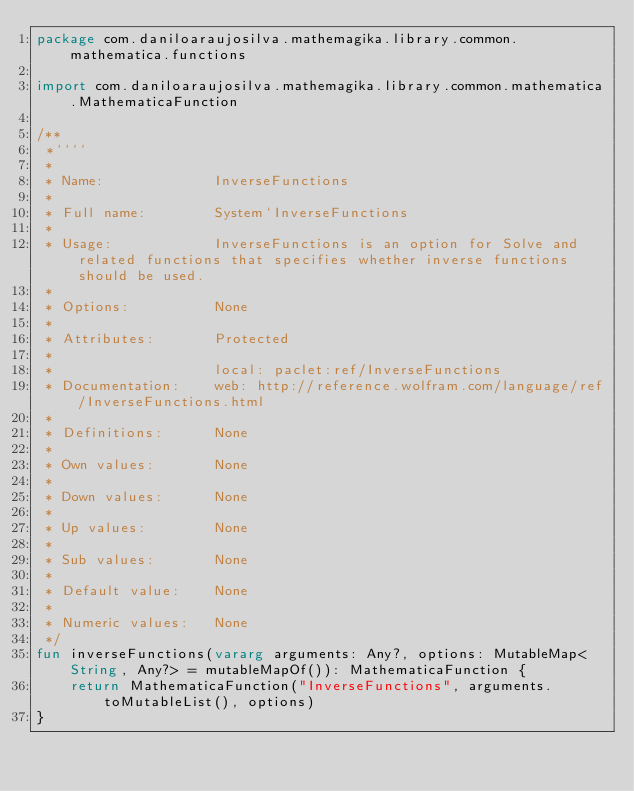Convert code to text. <code><loc_0><loc_0><loc_500><loc_500><_Kotlin_>package com.daniloaraujosilva.mathemagika.library.common.mathematica.functions

import com.daniloaraujosilva.mathemagika.library.common.mathematica.MathematicaFunction

/**
 *````
 *
 * Name:             InverseFunctions
 *
 * Full name:        System`InverseFunctions
 *
 * Usage:            InverseFunctions is an option for Solve and related functions that specifies whether inverse functions should be used.
 *
 * Options:          None
 *
 * Attributes:       Protected
 *
 *                   local: paclet:ref/InverseFunctions
 * Documentation:    web: http://reference.wolfram.com/language/ref/InverseFunctions.html
 *
 * Definitions:      None
 *
 * Own values:       None
 *
 * Down values:      None
 *
 * Up values:        None
 *
 * Sub values:       None
 *
 * Default value:    None
 *
 * Numeric values:   None
 */
fun inverseFunctions(vararg arguments: Any?, options: MutableMap<String, Any?> = mutableMapOf()): MathematicaFunction {
	return MathematicaFunction("InverseFunctions", arguments.toMutableList(), options)
}
</code> 